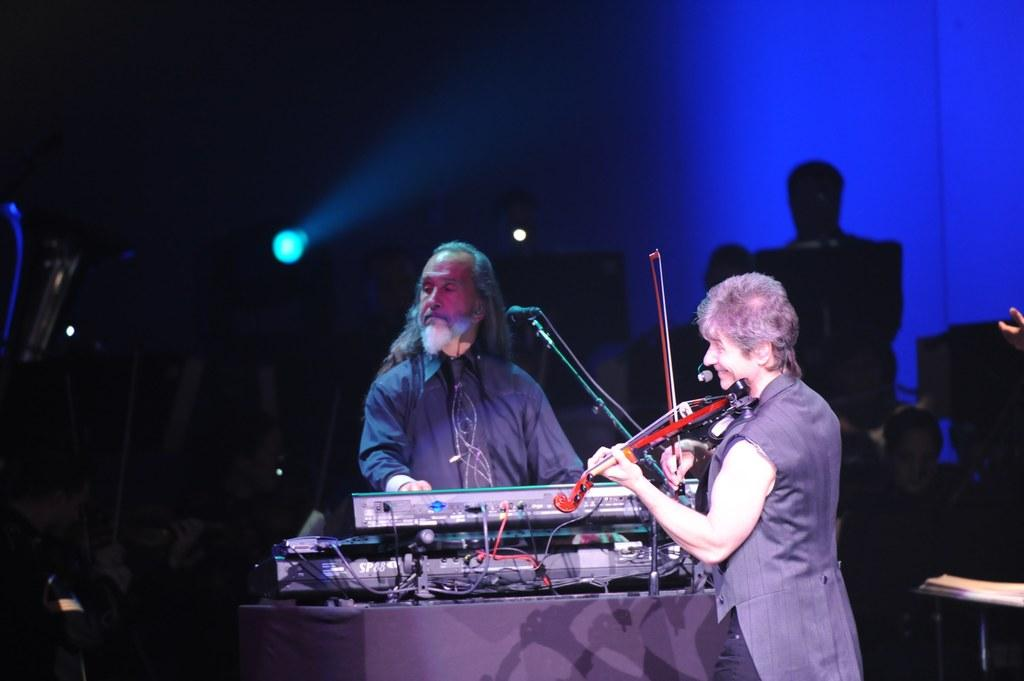What are the two people in the image doing? The two people in the image are playing musical instruments. Are there any other people present in the image? Yes, there are a few other people behind them. What can be seen in the background of the image? There are lights visible in the background of the image. What type of marble is being used as a stage for the performance in the image? There is no marble or stage visible in the image; it appears to be a casual setting with people playing musical instruments. 